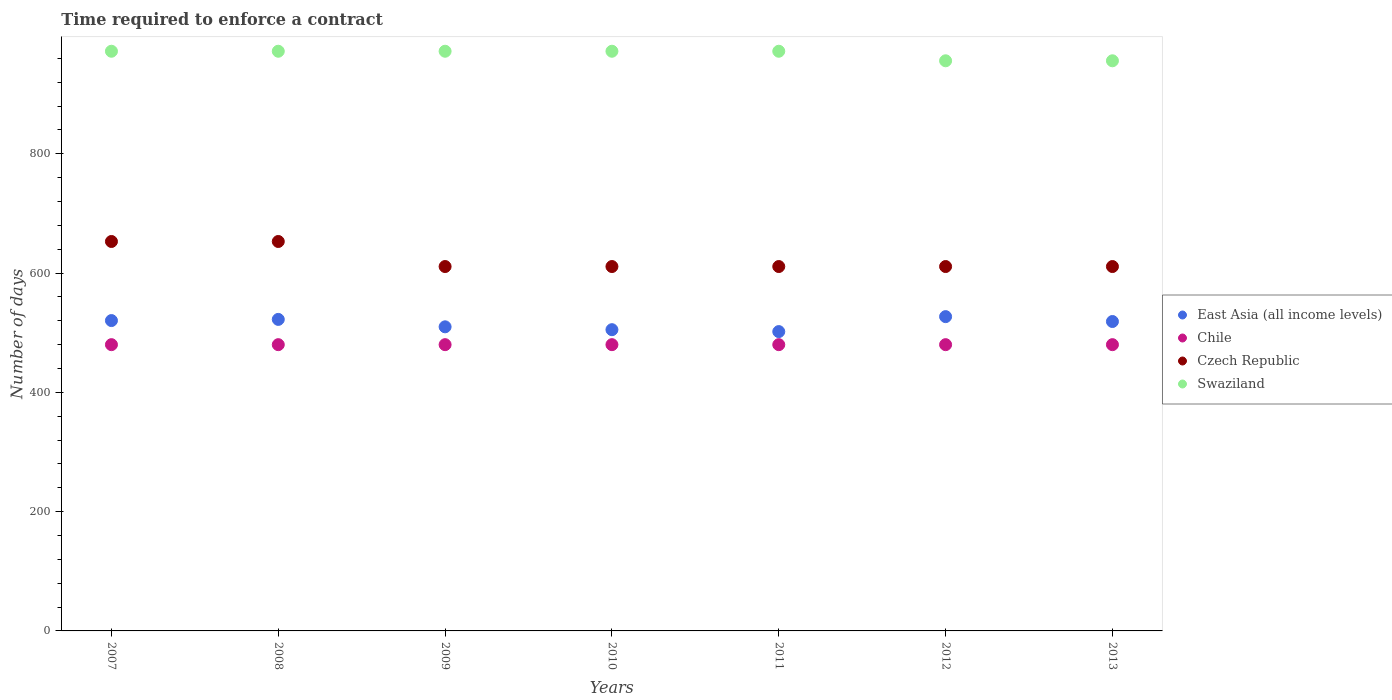How many different coloured dotlines are there?
Offer a terse response. 4. What is the number of days required to enforce a contract in Czech Republic in 2013?
Make the answer very short. 611. Across all years, what is the maximum number of days required to enforce a contract in Czech Republic?
Ensure brevity in your answer.  653. Across all years, what is the minimum number of days required to enforce a contract in East Asia (all income levels)?
Your answer should be compact. 501.92. In which year was the number of days required to enforce a contract in Swaziland maximum?
Offer a terse response. 2007. In which year was the number of days required to enforce a contract in East Asia (all income levels) minimum?
Make the answer very short. 2011. What is the total number of days required to enforce a contract in East Asia (all income levels) in the graph?
Your response must be concise. 3605.54. What is the difference between the number of days required to enforce a contract in Chile in 2009 and that in 2010?
Give a very brief answer. 0. What is the difference between the number of days required to enforce a contract in East Asia (all income levels) in 2011 and the number of days required to enforce a contract in Chile in 2007?
Offer a terse response. 21.92. What is the average number of days required to enforce a contract in Chile per year?
Offer a terse response. 480. In the year 2012, what is the difference between the number of days required to enforce a contract in Swaziland and number of days required to enforce a contract in Czech Republic?
Make the answer very short. 345. What is the difference between the highest and the second highest number of days required to enforce a contract in Swaziland?
Keep it short and to the point. 0. What is the difference between the highest and the lowest number of days required to enforce a contract in Swaziland?
Make the answer very short. 16. In how many years, is the number of days required to enforce a contract in Swaziland greater than the average number of days required to enforce a contract in Swaziland taken over all years?
Offer a terse response. 5. Is the sum of the number of days required to enforce a contract in Swaziland in 2012 and 2013 greater than the maximum number of days required to enforce a contract in East Asia (all income levels) across all years?
Make the answer very short. Yes. Is it the case that in every year, the sum of the number of days required to enforce a contract in Chile and number of days required to enforce a contract in Czech Republic  is greater than the sum of number of days required to enforce a contract in East Asia (all income levels) and number of days required to enforce a contract in Swaziland?
Provide a succinct answer. No. Is the number of days required to enforce a contract in Chile strictly less than the number of days required to enforce a contract in Swaziland over the years?
Your response must be concise. Yes. How many years are there in the graph?
Your answer should be compact. 7. What is the difference between two consecutive major ticks on the Y-axis?
Provide a short and direct response. 200. Are the values on the major ticks of Y-axis written in scientific E-notation?
Make the answer very short. No. How many legend labels are there?
Provide a short and direct response. 4. What is the title of the graph?
Give a very brief answer. Time required to enforce a contract. Does "Uzbekistan" appear as one of the legend labels in the graph?
Your answer should be compact. No. What is the label or title of the X-axis?
Provide a succinct answer. Years. What is the label or title of the Y-axis?
Offer a terse response. Number of days. What is the Number of days in East Asia (all income levels) in 2007?
Your answer should be very brief. 520.4. What is the Number of days of Chile in 2007?
Make the answer very short. 480. What is the Number of days of Czech Republic in 2007?
Your answer should be compact. 653. What is the Number of days of Swaziland in 2007?
Provide a short and direct response. 972. What is the Number of days in East Asia (all income levels) in 2008?
Give a very brief answer. 522.36. What is the Number of days of Chile in 2008?
Your answer should be very brief. 480. What is the Number of days in Czech Republic in 2008?
Make the answer very short. 653. What is the Number of days in Swaziland in 2008?
Give a very brief answer. 972. What is the Number of days of East Asia (all income levels) in 2009?
Give a very brief answer. 509.92. What is the Number of days in Chile in 2009?
Provide a succinct answer. 480. What is the Number of days in Czech Republic in 2009?
Make the answer very short. 611. What is the Number of days of Swaziland in 2009?
Provide a short and direct response. 972. What is the Number of days in East Asia (all income levels) in 2010?
Your answer should be compact. 505.12. What is the Number of days of Chile in 2010?
Provide a short and direct response. 480. What is the Number of days in Czech Republic in 2010?
Provide a succinct answer. 611. What is the Number of days in Swaziland in 2010?
Your response must be concise. 972. What is the Number of days in East Asia (all income levels) in 2011?
Your answer should be compact. 501.92. What is the Number of days in Chile in 2011?
Keep it short and to the point. 480. What is the Number of days of Czech Republic in 2011?
Offer a terse response. 611. What is the Number of days of Swaziland in 2011?
Your answer should be compact. 972. What is the Number of days in East Asia (all income levels) in 2012?
Your answer should be very brief. 527. What is the Number of days of Chile in 2012?
Your answer should be very brief. 480. What is the Number of days in Czech Republic in 2012?
Provide a succinct answer. 611. What is the Number of days in Swaziland in 2012?
Your response must be concise. 956. What is the Number of days of East Asia (all income levels) in 2013?
Make the answer very short. 518.82. What is the Number of days of Chile in 2013?
Keep it short and to the point. 480. What is the Number of days of Czech Republic in 2013?
Keep it short and to the point. 611. What is the Number of days in Swaziland in 2013?
Your response must be concise. 956. Across all years, what is the maximum Number of days in East Asia (all income levels)?
Your answer should be compact. 527. Across all years, what is the maximum Number of days in Chile?
Ensure brevity in your answer.  480. Across all years, what is the maximum Number of days of Czech Republic?
Offer a very short reply. 653. Across all years, what is the maximum Number of days in Swaziland?
Offer a terse response. 972. Across all years, what is the minimum Number of days in East Asia (all income levels)?
Ensure brevity in your answer.  501.92. Across all years, what is the minimum Number of days in Chile?
Make the answer very short. 480. Across all years, what is the minimum Number of days of Czech Republic?
Make the answer very short. 611. Across all years, what is the minimum Number of days of Swaziland?
Keep it short and to the point. 956. What is the total Number of days of East Asia (all income levels) in the graph?
Offer a terse response. 3605.54. What is the total Number of days of Chile in the graph?
Your answer should be very brief. 3360. What is the total Number of days of Czech Republic in the graph?
Your answer should be compact. 4361. What is the total Number of days of Swaziland in the graph?
Your answer should be very brief. 6772. What is the difference between the Number of days in East Asia (all income levels) in 2007 and that in 2008?
Keep it short and to the point. -1.96. What is the difference between the Number of days in East Asia (all income levels) in 2007 and that in 2009?
Your answer should be very brief. 10.48. What is the difference between the Number of days of Czech Republic in 2007 and that in 2009?
Your answer should be very brief. 42. What is the difference between the Number of days in East Asia (all income levels) in 2007 and that in 2010?
Give a very brief answer. 15.28. What is the difference between the Number of days of Czech Republic in 2007 and that in 2010?
Provide a succinct answer. 42. What is the difference between the Number of days in East Asia (all income levels) in 2007 and that in 2011?
Keep it short and to the point. 18.48. What is the difference between the Number of days of Swaziland in 2007 and that in 2011?
Your answer should be very brief. 0. What is the difference between the Number of days of East Asia (all income levels) in 2007 and that in 2012?
Offer a terse response. -6.6. What is the difference between the Number of days of Czech Republic in 2007 and that in 2012?
Provide a short and direct response. 42. What is the difference between the Number of days of East Asia (all income levels) in 2007 and that in 2013?
Provide a succinct answer. 1.58. What is the difference between the Number of days in East Asia (all income levels) in 2008 and that in 2009?
Your answer should be very brief. 12.44. What is the difference between the Number of days of East Asia (all income levels) in 2008 and that in 2010?
Give a very brief answer. 17.24. What is the difference between the Number of days in Chile in 2008 and that in 2010?
Offer a very short reply. 0. What is the difference between the Number of days of Swaziland in 2008 and that in 2010?
Your response must be concise. 0. What is the difference between the Number of days in East Asia (all income levels) in 2008 and that in 2011?
Keep it short and to the point. 20.44. What is the difference between the Number of days of Czech Republic in 2008 and that in 2011?
Offer a very short reply. 42. What is the difference between the Number of days in East Asia (all income levels) in 2008 and that in 2012?
Your answer should be very brief. -4.64. What is the difference between the Number of days in Chile in 2008 and that in 2012?
Your response must be concise. 0. What is the difference between the Number of days in Czech Republic in 2008 and that in 2012?
Keep it short and to the point. 42. What is the difference between the Number of days of Swaziland in 2008 and that in 2012?
Make the answer very short. 16. What is the difference between the Number of days of East Asia (all income levels) in 2008 and that in 2013?
Provide a short and direct response. 3.54. What is the difference between the Number of days in Chile in 2008 and that in 2013?
Give a very brief answer. 0. What is the difference between the Number of days in Czech Republic in 2008 and that in 2013?
Give a very brief answer. 42. What is the difference between the Number of days of East Asia (all income levels) in 2009 and that in 2011?
Offer a terse response. 8. What is the difference between the Number of days in Swaziland in 2009 and that in 2011?
Ensure brevity in your answer.  0. What is the difference between the Number of days of East Asia (all income levels) in 2009 and that in 2012?
Provide a succinct answer. -17.08. What is the difference between the Number of days in Czech Republic in 2009 and that in 2012?
Your response must be concise. 0. What is the difference between the Number of days in Swaziland in 2009 and that in 2012?
Offer a terse response. 16. What is the difference between the Number of days of East Asia (all income levels) in 2009 and that in 2013?
Provide a succinct answer. -8.9. What is the difference between the Number of days in Czech Republic in 2009 and that in 2013?
Your answer should be compact. 0. What is the difference between the Number of days in East Asia (all income levels) in 2010 and that in 2011?
Make the answer very short. 3.2. What is the difference between the Number of days of Chile in 2010 and that in 2011?
Your response must be concise. 0. What is the difference between the Number of days in Swaziland in 2010 and that in 2011?
Make the answer very short. 0. What is the difference between the Number of days in East Asia (all income levels) in 2010 and that in 2012?
Offer a very short reply. -21.88. What is the difference between the Number of days in Swaziland in 2010 and that in 2012?
Offer a very short reply. 16. What is the difference between the Number of days in East Asia (all income levels) in 2010 and that in 2013?
Keep it short and to the point. -13.7. What is the difference between the Number of days of Chile in 2010 and that in 2013?
Provide a succinct answer. 0. What is the difference between the Number of days of East Asia (all income levels) in 2011 and that in 2012?
Ensure brevity in your answer.  -25.08. What is the difference between the Number of days in Czech Republic in 2011 and that in 2012?
Offer a terse response. 0. What is the difference between the Number of days of East Asia (all income levels) in 2011 and that in 2013?
Make the answer very short. -16.9. What is the difference between the Number of days in Czech Republic in 2011 and that in 2013?
Provide a short and direct response. 0. What is the difference between the Number of days in East Asia (all income levels) in 2012 and that in 2013?
Your answer should be compact. 8.18. What is the difference between the Number of days of Czech Republic in 2012 and that in 2013?
Offer a very short reply. 0. What is the difference between the Number of days of Swaziland in 2012 and that in 2013?
Provide a short and direct response. 0. What is the difference between the Number of days of East Asia (all income levels) in 2007 and the Number of days of Chile in 2008?
Make the answer very short. 40.4. What is the difference between the Number of days in East Asia (all income levels) in 2007 and the Number of days in Czech Republic in 2008?
Make the answer very short. -132.6. What is the difference between the Number of days in East Asia (all income levels) in 2007 and the Number of days in Swaziland in 2008?
Provide a short and direct response. -451.6. What is the difference between the Number of days of Chile in 2007 and the Number of days of Czech Republic in 2008?
Provide a succinct answer. -173. What is the difference between the Number of days in Chile in 2007 and the Number of days in Swaziland in 2008?
Make the answer very short. -492. What is the difference between the Number of days in Czech Republic in 2007 and the Number of days in Swaziland in 2008?
Make the answer very short. -319. What is the difference between the Number of days in East Asia (all income levels) in 2007 and the Number of days in Chile in 2009?
Keep it short and to the point. 40.4. What is the difference between the Number of days in East Asia (all income levels) in 2007 and the Number of days in Czech Republic in 2009?
Give a very brief answer. -90.6. What is the difference between the Number of days of East Asia (all income levels) in 2007 and the Number of days of Swaziland in 2009?
Ensure brevity in your answer.  -451.6. What is the difference between the Number of days in Chile in 2007 and the Number of days in Czech Republic in 2009?
Ensure brevity in your answer.  -131. What is the difference between the Number of days in Chile in 2007 and the Number of days in Swaziland in 2009?
Keep it short and to the point. -492. What is the difference between the Number of days of Czech Republic in 2007 and the Number of days of Swaziland in 2009?
Give a very brief answer. -319. What is the difference between the Number of days of East Asia (all income levels) in 2007 and the Number of days of Chile in 2010?
Provide a succinct answer. 40.4. What is the difference between the Number of days in East Asia (all income levels) in 2007 and the Number of days in Czech Republic in 2010?
Your answer should be very brief. -90.6. What is the difference between the Number of days in East Asia (all income levels) in 2007 and the Number of days in Swaziland in 2010?
Provide a succinct answer. -451.6. What is the difference between the Number of days of Chile in 2007 and the Number of days of Czech Republic in 2010?
Your response must be concise. -131. What is the difference between the Number of days in Chile in 2007 and the Number of days in Swaziland in 2010?
Provide a succinct answer. -492. What is the difference between the Number of days of Czech Republic in 2007 and the Number of days of Swaziland in 2010?
Ensure brevity in your answer.  -319. What is the difference between the Number of days of East Asia (all income levels) in 2007 and the Number of days of Chile in 2011?
Give a very brief answer. 40.4. What is the difference between the Number of days in East Asia (all income levels) in 2007 and the Number of days in Czech Republic in 2011?
Offer a very short reply. -90.6. What is the difference between the Number of days of East Asia (all income levels) in 2007 and the Number of days of Swaziland in 2011?
Make the answer very short. -451.6. What is the difference between the Number of days in Chile in 2007 and the Number of days in Czech Republic in 2011?
Your answer should be very brief. -131. What is the difference between the Number of days of Chile in 2007 and the Number of days of Swaziland in 2011?
Your response must be concise. -492. What is the difference between the Number of days in Czech Republic in 2007 and the Number of days in Swaziland in 2011?
Offer a terse response. -319. What is the difference between the Number of days in East Asia (all income levels) in 2007 and the Number of days in Chile in 2012?
Give a very brief answer. 40.4. What is the difference between the Number of days in East Asia (all income levels) in 2007 and the Number of days in Czech Republic in 2012?
Make the answer very short. -90.6. What is the difference between the Number of days in East Asia (all income levels) in 2007 and the Number of days in Swaziland in 2012?
Keep it short and to the point. -435.6. What is the difference between the Number of days of Chile in 2007 and the Number of days of Czech Republic in 2012?
Your answer should be compact. -131. What is the difference between the Number of days of Chile in 2007 and the Number of days of Swaziland in 2012?
Your answer should be compact. -476. What is the difference between the Number of days of Czech Republic in 2007 and the Number of days of Swaziland in 2012?
Your response must be concise. -303. What is the difference between the Number of days in East Asia (all income levels) in 2007 and the Number of days in Chile in 2013?
Offer a terse response. 40.4. What is the difference between the Number of days of East Asia (all income levels) in 2007 and the Number of days of Czech Republic in 2013?
Your answer should be compact. -90.6. What is the difference between the Number of days in East Asia (all income levels) in 2007 and the Number of days in Swaziland in 2013?
Offer a very short reply. -435.6. What is the difference between the Number of days of Chile in 2007 and the Number of days of Czech Republic in 2013?
Keep it short and to the point. -131. What is the difference between the Number of days in Chile in 2007 and the Number of days in Swaziland in 2013?
Make the answer very short. -476. What is the difference between the Number of days of Czech Republic in 2007 and the Number of days of Swaziland in 2013?
Ensure brevity in your answer.  -303. What is the difference between the Number of days in East Asia (all income levels) in 2008 and the Number of days in Chile in 2009?
Make the answer very short. 42.36. What is the difference between the Number of days in East Asia (all income levels) in 2008 and the Number of days in Czech Republic in 2009?
Make the answer very short. -88.64. What is the difference between the Number of days of East Asia (all income levels) in 2008 and the Number of days of Swaziland in 2009?
Provide a succinct answer. -449.64. What is the difference between the Number of days of Chile in 2008 and the Number of days of Czech Republic in 2009?
Your answer should be compact. -131. What is the difference between the Number of days in Chile in 2008 and the Number of days in Swaziland in 2009?
Offer a very short reply. -492. What is the difference between the Number of days in Czech Republic in 2008 and the Number of days in Swaziland in 2009?
Keep it short and to the point. -319. What is the difference between the Number of days in East Asia (all income levels) in 2008 and the Number of days in Chile in 2010?
Ensure brevity in your answer.  42.36. What is the difference between the Number of days in East Asia (all income levels) in 2008 and the Number of days in Czech Republic in 2010?
Provide a succinct answer. -88.64. What is the difference between the Number of days of East Asia (all income levels) in 2008 and the Number of days of Swaziland in 2010?
Provide a succinct answer. -449.64. What is the difference between the Number of days in Chile in 2008 and the Number of days in Czech Republic in 2010?
Offer a terse response. -131. What is the difference between the Number of days in Chile in 2008 and the Number of days in Swaziland in 2010?
Provide a succinct answer. -492. What is the difference between the Number of days in Czech Republic in 2008 and the Number of days in Swaziland in 2010?
Your answer should be very brief. -319. What is the difference between the Number of days of East Asia (all income levels) in 2008 and the Number of days of Chile in 2011?
Make the answer very short. 42.36. What is the difference between the Number of days in East Asia (all income levels) in 2008 and the Number of days in Czech Republic in 2011?
Give a very brief answer. -88.64. What is the difference between the Number of days of East Asia (all income levels) in 2008 and the Number of days of Swaziland in 2011?
Ensure brevity in your answer.  -449.64. What is the difference between the Number of days of Chile in 2008 and the Number of days of Czech Republic in 2011?
Ensure brevity in your answer.  -131. What is the difference between the Number of days of Chile in 2008 and the Number of days of Swaziland in 2011?
Ensure brevity in your answer.  -492. What is the difference between the Number of days of Czech Republic in 2008 and the Number of days of Swaziland in 2011?
Offer a very short reply. -319. What is the difference between the Number of days in East Asia (all income levels) in 2008 and the Number of days in Chile in 2012?
Give a very brief answer. 42.36. What is the difference between the Number of days in East Asia (all income levels) in 2008 and the Number of days in Czech Republic in 2012?
Give a very brief answer. -88.64. What is the difference between the Number of days in East Asia (all income levels) in 2008 and the Number of days in Swaziland in 2012?
Make the answer very short. -433.64. What is the difference between the Number of days of Chile in 2008 and the Number of days of Czech Republic in 2012?
Your answer should be very brief. -131. What is the difference between the Number of days in Chile in 2008 and the Number of days in Swaziland in 2012?
Ensure brevity in your answer.  -476. What is the difference between the Number of days of Czech Republic in 2008 and the Number of days of Swaziland in 2012?
Offer a terse response. -303. What is the difference between the Number of days in East Asia (all income levels) in 2008 and the Number of days in Chile in 2013?
Provide a short and direct response. 42.36. What is the difference between the Number of days of East Asia (all income levels) in 2008 and the Number of days of Czech Republic in 2013?
Offer a very short reply. -88.64. What is the difference between the Number of days in East Asia (all income levels) in 2008 and the Number of days in Swaziland in 2013?
Offer a very short reply. -433.64. What is the difference between the Number of days in Chile in 2008 and the Number of days in Czech Republic in 2013?
Your answer should be compact. -131. What is the difference between the Number of days of Chile in 2008 and the Number of days of Swaziland in 2013?
Your response must be concise. -476. What is the difference between the Number of days in Czech Republic in 2008 and the Number of days in Swaziland in 2013?
Your response must be concise. -303. What is the difference between the Number of days in East Asia (all income levels) in 2009 and the Number of days in Chile in 2010?
Provide a succinct answer. 29.92. What is the difference between the Number of days of East Asia (all income levels) in 2009 and the Number of days of Czech Republic in 2010?
Your response must be concise. -101.08. What is the difference between the Number of days in East Asia (all income levels) in 2009 and the Number of days in Swaziland in 2010?
Make the answer very short. -462.08. What is the difference between the Number of days in Chile in 2009 and the Number of days in Czech Republic in 2010?
Offer a very short reply. -131. What is the difference between the Number of days of Chile in 2009 and the Number of days of Swaziland in 2010?
Keep it short and to the point. -492. What is the difference between the Number of days in Czech Republic in 2009 and the Number of days in Swaziland in 2010?
Your answer should be very brief. -361. What is the difference between the Number of days of East Asia (all income levels) in 2009 and the Number of days of Chile in 2011?
Your answer should be very brief. 29.92. What is the difference between the Number of days in East Asia (all income levels) in 2009 and the Number of days in Czech Republic in 2011?
Give a very brief answer. -101.08. What is the difference between the Number of days of East Asia (all income levels) in 2009 and the Number of days of Swaziland in 2011?
Provide a short and direct response. -462.08. What is the difference between the Number of days of Chile in 2009 and the Number of days of Czech Republic in 2011?
Keep it short and to the point. -131. What is the difference between the Number of days in Chile in 2009 and the Number of days in Swaziland in 2011?
Keep it short and to the point. -492. What is the difference between the Number of days in Czech Republic in 2009 and the Number of days in Swaziland in 2011?
Your answer should be compact. -361. What is the difference between the Number of days of East Asia (all income levels) in 2009 and the Number of days of Chile in 2012?
Keep it short and to the point. 29.92. What is the difference between the Number of days in East Asia (all income levels) in 2009 and the Number of days in Czech Republic in 2012?
Offer a very short reply. -101.08. What is the difference between the Number of days in East Asia (all income levels) in 2009 and the Number of days in Swaziland in 2012?
Keep it short and to the point. -446.08. What is the difference between the Number of days of Chile in 2009 and the Number of days of Czech Republic in 2012?
Offer a very short reply. -131. What is the difference between the Number of days of Chile in 2009 and the Number of days of Swaziland in 2012?
Keep it short and to the point. -476. What is the difference between the Number of days of Czech Republic in 2009 and the Number of days of Swaziland in 2012?
Offer a terse response. -345. What is the difference between the Number of days in East Asia (all income levels) in 2009 and the Number of days in Chile in 2013?
Ensure brevity in your answer.  29.92. What is the difference between the Number of days in East Asia (all income levels) in 2009 and the Number of days in Czech Republic in 2013?
Keep it short and to the point. -101.08. What is the difference between the Number of days in East Asia (all income levels) in 2009 and the Number of days in Swaziland in 2013?
Offer a very short reply. -446.08. What is the difference between the Number of days of Chile in 2009 and the Number of days of Czech Republic in 2013?
Ensure brevity in your answer.  -131. What is the difference between the Number of days in Chile in 2009 and the Number of days in Swaziland in 2013?
Give a very brief answer. -476. What is the difference between the Number of days of Czech Republic in 2009 and the Number of days of Swaziland in 2013?
Ensure brevity in your answer.  -345. What is the difference between the Number of days of East Asia (all income levels) in 2010 and the Number of days of Chile in 2011?
Make the answer very short. 25.12. What is the difference between the Number of days in East Asia (all income levels) in 2010 and the Number of days in Czech Republic in 2011?
Your answer should be compact. -105.88. What is the difference between the Number of days in East Asia (all income levels) in 2010 and the Number of days in Swaziland in 2011?
Make the answer very short. -466.88. What is the difference between the Number of days of Chile in 2010 and the Number of days of Czech Republic in 2011?
Provide a short and direct response. -131. What is the difference between the Number of days in Chile in 2010 and the Number of days in Swaziland in 2011?
Your answer should be very brief. -492. What is the difference between the Number of days of Czech Republic in 2010 and the Number of days of Swaziland in 2011?
Ensure brevity in your answer.  -361. What is the difference between the Number of days of East Asia (all income levels) in 2010 and the Number of days of Chile in 2012?
Give a very brief answer. 25.12. What is the difference between the Number of days of East Asia (all income levels) in 2010 and the Number of days of Czech Republic in 2012?
Keep it short and to the point. -105.88. What is the difference between the Number of days in East Asia (all income levels) in 2010 and the Number of days in Swaziland in 2012?
Make the answer very short. -450.88. What is the difference between the Number of days in Chile in 2010 and the Number of days in Czech Republic in 2012?
Your response must be concise. -131. What is the difference between the Number of days of Chile in 2010 and the Number of days of Swaziland in 2012?
Provide a succinct answer. -476. What is the difference between the Number of days in Czech Republic in 2010 and the Number of days in Swaziland in 2012?
Give a very brief answer. -345. What is the difference between the Number of days in East Asia (all income levels) in 2010 and the Number of days in Chile in 2013?
Give a very brief answer. 25.12. What is the difference between the Number of days of East Asia (all income levels) in 2010 and the Number of days of Czech Republic in 2013?
Offer a terse response. -105.88. What is the difference between the Number of days of East Asia (all income levels) in 2010 and the Number of days of Swaziland in 2013?
Ensure brevity in your answer.  -450.88. What is the difference between the Number of days of Chile in 2010 and the Number of days of Czech Republic in 2013?
Ensure brevity in your answer.  -131. What is the difference between the Number of days of Chile in 2010 and the Number of days of Swaziland in 2013?
Your answer should be compact. -476. What is the difference between the Number of days in Czech Republic in 2010 and the Number of days in Swaziland in 2013?
Your answer should be very brief. -345. What is the difference between the Number of days of East Asia (all income levels) in 2011 and the Number of days of Chile in 2012?
Ensure brevity in your answer.  21.92. What is the difference between the Number of days in East Asia (all income levels) in 2011 and the Number of days in Czech Republic in 2012?
Provide a short and direct response. -109.08. What is the difference between the Number of days in East Asia (all income levels) in 2011 and the Number of days in Swaziland in 2012?
Your response must be concise. -454.08. What is the difference between the Number of days in Chile in 2011 and the Number of days in Czech Republic in 2012?
Your answer should be compact. -131. What is the difference between the Number of days of Chile in 2011 and the Number of days of Swaziland in 2012?
Your answer should be very brief. -476. What is the difference between the Number of days of Czech Republic in 2011 and the Number of days of Swaziland in 2012?
Provide a short and direct response. -345. What is the difference between the Number of days of East Asia (all income levels) in 2011 and the Number of days of Chile in 2013?
Make the answer very short. 21.92. What is the difference between the Number of days of East Asia (all income levels) in 2011 and the Number of days of Czech Republic in 2013?
Provide a short and direct response. -109.08. What is the difference between the Number of days in East Asia (all income levels) in 2011 and the Number of days in Swaziland in 2013?
Provide a succinct answer. -454.08. What is the difference between the Number of days of Chile in 2011 and the Number of days of Czech Republic in 2013?
Keep it short and to the point. -131. What is the difference between the Number of days in Chile in 2011 and the Number of days in Swaziland in 2013?
Provide a succinct answer. -476. What is the difference between the Number of days in Czech Republic in 2011 and the Number of days in Swaziland in 2013?
Provide a succinct answer. -345. What is the difference between the Number of days of East Asia (all income levels) in 2012 and the Number of days of Chile in 2013?
Keep it short and to the point. 47. What is the difference between the Number of days of East Asia (all income levels) in 2012 and the Number of days of Czech Republic in 2013?
Provide a short and direct response. -84. What is the difference between the Number of days of East Asia (all income levels) in 2012 and the Number of days of Swaziland in 2013?
Your answer should be compact. -429. What is the difference between the Number of days in Chile in 2012 and the Number of days in Czech Republic in 2013?
Offer a terse response. -131. What is the difference between the Number of days in Chile in 2012 and the Number of days in Swaziland in 2013?
Provide a succinct answer. -476. What is the difference between the Number of days in Czech Republic in 2012 and the Number of days in Swaziland in 2013?
Provide a succinct answer. -345. What is the average Number of days of East Asia (all income levels) per year?
Keep it short and to the point. 515.08. What is the average Number of days in Chile per year?
Provide a succinct answer. 480. What is the average Number of days in Czech Republic per year?
Offer a terse response. 623. What is the average Number of days of Swaziland per year?
Your answer should be very brief. 967.43. In the year 2007, what is the difference between the Number of days in East Asia (all income levels) and Number of days in Chile?
Make the answer very short. 40.4. In the year 2007, what is the difference between the Number of days in East Asia (all income levels) and Number of days in Czech Republic?
Give a very brief answer. -132.6. In the year 2007, what is the difference between the Number of days of East Asia (all income levels) and Number of days of Swaziland?
Ensure brevity in your answer.  -451.6. In the year 2007, what is the difference between the Number of days of Chile and Number of days of Czech Republic?
Your answer should be compact. -173. In the year 2007, what is the difference between the Number of days in Chile and Number of days in Swaziland?
Offer a very short reply. -492. In the year 2007, what is the difference between the Number of days of Czech Republic and Number of days of Swaziland?
Provide a short and direct response. -319. In the year 2008, what is the difference between the Number of days of East Asia (all income levels) and Number of days of Chile?
Give a very brief answer. 42.36. In the year 2008, what is the difference between the Number of days in East Asia (all income levels) and Number of days in Czech Republic?
Provide a succinct answer. -130.64. In the year 2008, what is the difference between the Number of days of East Asia (all income levels) and Number of days of Swaziland?
Make the answer very short. -449.64. In the year 2008, what is the difference between the Number of days in Chile and Number of days in Czech Republic?
Make the answer very short. -173. In the year 2008, what is the difference between the Number of days of Chile and Number of days of Swaziland?
Offer a very short reply. -492. In the year 2008, what is the difference between the Number of days in Czech Republic and Number of days in Swaziland?
Ensure brevity in your answer.  -319. In the year 2009, what is the difference between the Number of days in East Asia (all income levels) and Number of days in Chile?
Provide a short and direct response. 29.92. In the year 2009, what is the difference between the Number of days in East Asia (all income levels) and Number of days in Czech Republic?
Ensure brevity in your answer.  -101.08. In the year 2009, what is the difference between the Number of days in East Asia (all income levels) and Number of days in Swaziland?
Provide a short and direct response. -462.08. In the year 2009, what is the difference between the Number of days in Chile and Number of days in Czech Republic?
Provide a succinct answer. -131. In the year 2009, what is the difference between the Number of days of Chile and Number of days of Swaziland?
Give a very brief answer. -492. In the year 2009, what is the difference between the Number of days of Czech Republic and Number of days of Swaziland?
Your response must be concise. -361. In the year 2010, what is the difference between the Number of days of East Asia (all income levels) and Number of days of Chile?
Keep it short and to the point. 25.12. In the year 2010, what is the difference between the Number of days of East Asia (all income levels) and Number of days of Czech Republic?
Provide a succinct answer. -105.88. In the year 2010, what is the difference between the Number of days of East Asia (all income levels) and Number of days of Swaziland?
Offer a terse response. -466.88. In the year 2010, what is the difference between the Number of days of Chile and Number of days of Czech Republic?
Your response must be concise. -131. In the year 2010, what is the difference between the Number of days in Chile and Number of days in Swaziland?
Make the answer very short. -492. In the year 2010, what is the difference between the Number of days in Czech Republic and Number of days in Swaziland?
Make the answer very short. -361. In the year 2011, what is the difference between the Number of days of East Asia (all income levels) and Number of days of Chile?
Keep it short and to the point. 21.92. In the year 2011, what is the difference between the Number of days in East Asia (all income levels) and Number of days in Czech Republic?
Provide a short and direct response. -109.08. In the year 2011, what is the difference between the Number of days of East Asia (all income levels) and Number of days of Swaziland?
Offer a terse response. -470.08. In the year 2011, what is the difference between the Number of days of Chile and Number of days of Czech Republic?
Provide a succinct answer. -131. In the year 2011, what is the difference between the Number of days in Chile and Number of days in Swaziland?
Your response must be concise. -492. In the year 2011, what is the difference between the Number of days of Czech Republic and Number of days of Swaziland?
Make the answer very short. -361. In the year 2012, what is the difference between the Number of days in East Asia (all income levels) and Number of days in Chile?
Give a very brief answer. 47. In the year 2012, what is the difference between the Number of days of East Asia (all income levels) and Number of days of Czech Republic?
Offer a terse response. -84. In the year 2012, what is the difference between the Number of days in East Asia (all income levels) and Number of days in Swaziland?
Keep it short and to the point. -429. In the year 2012, what is the difference between the Number of days of Chile and Number of days of Czech Republic?
Your response must be concise. -131. In the year 2012, what is the difference between the Number of days of Chile and Number of days of Swaziland?
Keep it short and to the point. -476. In the year 2012, what is the difference between the Number of days of Czech Republic and Number of days of Swaziland?
Give a very brief answer. -345. In the year 2013, what is the difference between the Number of days in East Asia (all income levels) and Number of days in Chile?
Your answer should be very brief. 38.82. In the year 2013, what is the difference between the Number of days in East Asia (all income levels) and Number of days in Czech Republic?
Offer a terse response. -92.18. In the year 2013, what is the difference between the Number of days in East Asia (all income levels) and Number of days in Swaziland?
Provide a succinct answer. -437.18. In the year 2013, what is the difference between the Number of days of Chile and Number of days of Czech Republic?
Make the answer very short. -131. In the year 2013, what is the difference between the Number of days in Chile and Number of days in Swaziland?
Offer a terse response. -476. In the year 2013, what is the difference between the Number of days of Czech Republic and Number of days of Swaziland?
Offer a very short reply. -345. What is the ratio of the Number of days in East Asia (all income levels) in 2007 to that in 2008?
Provide a short and direct response. 1. What is the ratio of the Number of days in Chile in 2007 to that in 2008?
Make the answer very short. 1. What is the ratio of the Number of days of Swaziland in 2007 to that in 2008?
Offer a very short reply. 1. What is the ratio of the Number of days of East Asia (all income levels) in 2007 to that in 2009?
Ensure brevity in your answer.  1.02. What is the ratio of the Number of days in Czech Republic in 2007 to that in 2009?
Provide a short and direct response. 1.07. What is the ratio of the Number of days in East Asia (all income levels) in 2007 to that in 2010?
Keep it short and to the point. 1.03. What is the ratio of the Number of days of Czech Republic in 2007 to that in 2010?
Give a very brief answer. 1.07. What is the ratio of the Number of days in Swaziland in 2007 to that in 2010?
Your answer should be compact. 1. What is the ratio of the Number of days of East Asia (all income levels) in 2007 to that in 2011?
Ensure brevity in your answer.  1.04. What is the ratio of the Number of days of Czech Republic in 2007 to that in 2011?
Your response must be concise. 1.07. What is the ratio of the Number of days in East Asia (all income levels) in 2007 to that in 2012?
Make the answer very short. 0.99. What is the ratio of the Number of days of Czech Republic in 2007 to that in 2012?
Provide a succinct answer. 1.07. What is the ratio of the Number of days in Swaziland in 2007 to that in 2012?
Provide a succinct answer. 1.02. What is the ratio of the Number of days in East Asia (all income levels) in 2007 to that in 2013?
Your answer should be compact. 1. What is the ratio of the Number of days of Czech Republic in 2007 to that in 2013?
Keep it short and to the point. 1.07. What is the ratio of the Number of days of Swaziland in 2007 to that in 2013?
Make the answer very short. 1.02. What is the ratio of the Number of days of East Asia (all income levels) in 2008 to that in 2009?
Offer a very short reply. 1.02. What is the ratio of the Number of days of Czech Republic in 2008 to that in 2009?
Offer a terse response. 1.07. What is the ratio of the Number of days in Swaziland in 2008 to that in 2009?
Provide a short and direct response. 1. What is the ratio of the Number of days of East Asia (all income levels) in 2008 to that in 2010?
Provide a short and direct response. 1.03. What is the ratio of the Number of days in Chile in 2008 to that in 2010?
Ensure brevity in your answer.  1. What is the ratio of the Number of days in Czech Republic in 2008 to that in 2010?
Keep it short and to the point. 1.07. What is the ratio of the Number of days of East Asia (all income levels) in 2008 to that in 2011?
Make the answer very short. 1.04. What is the ratio of the Number of days in Chile in 2008 to that in 2011?
Keep it short and to the point. 1. What is the ratio of the Number of days in Czech Republic in 2008 to that in 2011?
Your response must be concise. 1.07. What is the ratio of the Number of days in Czech Republic in 2008 to that in 2012?
Keep it short and to the point. 1.07. What is the ratio of the Number of days of Swaziland in 2008 to that in 2012?
Keep it short and to the point. 1.02. What is the ratio of the Number of days of East Asia (all income levels) in 2008 to that in 2013?
Provide a short and direct response. 1.01. What is the ratio of the Number of days in Chile in 2008 to that in 2013?
Your answer should be very brief. 1. What is the ratio of the Number of days in Czech Republic in 2008 to that in 2013?
Ensure brevity in your answer.  1.07. What is the ratio of the Number of days in Swaziland in 2008 to that in 2013?
Provide a short and direct response. 1.02. What is the ratio of the Number of days of East Asia (all income levels) in 2009 to that in 2010?
Give a very brief answer. 1.01. What is the ratio of the Number of days in Chile in 2009 to that in 2010?
Offer a very short reply. 1. What is the ratio of the Number of days in Czech Republic in 2009 to that in 2010?
Provide a succinct answer. 1. What is the ratio of the Number of days in Swaziland in 2009 to that in 2010?
Your answer should be very brief. 1. What is the ratio of the Number of days of East Asia (all income levels) in 2009 to that in 2011?
Offer a terse response. 1.02. What is the ratio of the Number of days of Chile in 2009 to that in 2011?
Keep it short and to the point. 1. What is the ratio of the Number of days in Czech Republic in 2009 to that in 2011?
Ensure brevity in your answer.  1. What is the ratio of the Number of days of Swaziland in 2009 to that in 2011?
Ensure brevity in your answer.  1. What is the ratio of the Number of days in East Asia (all income levels) in 2009 to that in 2012?
Your response must be concise. 0.97. What is the ratio of the Number of days of Chile in 2009 to that in 2012?
Your answer should be very brief. 1. What is the ratio of the Number of days in Czech Republic in 2009 to that in 2012?
Provide a short and direct response. 1. What is the ratio of the Number of days of Swaziland in 2009 to that in 2012?
Give a very brief answer. 1.02. What is the ratio of the Number of days of East Asia (all income levels) in 2009 to that in 2013?
Your response must be concise. 0.98. What is the ratio of the Number of days in Czech Republic in 2009 to that in 2013?
Offer a very short reply. 1. What is the ratio of the Number of days of Swaziland in 2009 to that in 2013?
Keep it short and to the point. 1.02. What is the ratio of the Number of days of East Asia (all income levels) in 2010 to that in 2011?
Offer a terse response. 1.01. What is the ratio of the Number of days of Chile in 2010 to that in 2011?
Provide a succinct answer. 1. What is the ratio of the Number of days in Czech Republic in 2010 to that in 2011?
Provide a short and direct response. 1. What is the ratio of the Number of days of Swaziland in 2010 to that in 2011?
Provide a succinct answer. 1. What is the ratio of the Number of days of East Asia (all income levels) in 2010 to that in 2012?
Your answer should be compact. 0.96. What is the ratio of the Number of days of Swaziland in 2010 to that in 2012?
Offer a terse response. 1.02. What is the ratio of the Number of days in East Asia (all income levels) in 2010 to that in 2013?
Your answer should be very brief. 0.97. What is the ratio of the Number of days of Chile in 2010 to that in 2013?
Your answer should be very brief. 1. What is the ratio of the Number of days of Swaziland in 2010 to that in 2013?
Provide a short and direct response. 1.02. What is the ratio of the Number of days of Chile in 2011 to that in 2012?
Your answer should be compact. 1. What is the ratio of the Number of days of Czech Republic in 2011 to that in 2012?
Ensure brevity in your answer.  1. What is the ratio of the Number of days of Swaziland in 2011 to that in 2012?
Provide a short and direct response. 1.02. What is the ratio of the Number of days of East Asia (all income levels) in 2011 to that in 2013?
Your response must be concise. 0.97. What is the ratio of the Number of days of Swaziland in 2011 to that in 2013?
Keep it short and to the point. 1.02. What is the ratio of the Number of days in East Asia (all income levels) in 2012 to that in 2013?
Offer a terse response. 1.02. What is the ratio of the Number of days of Chile in 2012 to that in 2013?
Your response must be concise. 1. What is the difference between the highest and the second highest Number of days in East Asia (all income levels)?
Keep it short and to the point. 4.64. What is the difference between the highest and the second highest Number of days in Chile?
Offer a very short reply. 0. What is the difference between the highest and the lowest Number of days of East Asia (all income levels)?
Your answer should be compact. 25.08. What is the difference between the highest and the lowest Number of days of Chile?
Provide a succinct answer. 0. What is the difference between the highest and the lowest Number of days in Swaziland?
Provide a short and direct response. 16. 